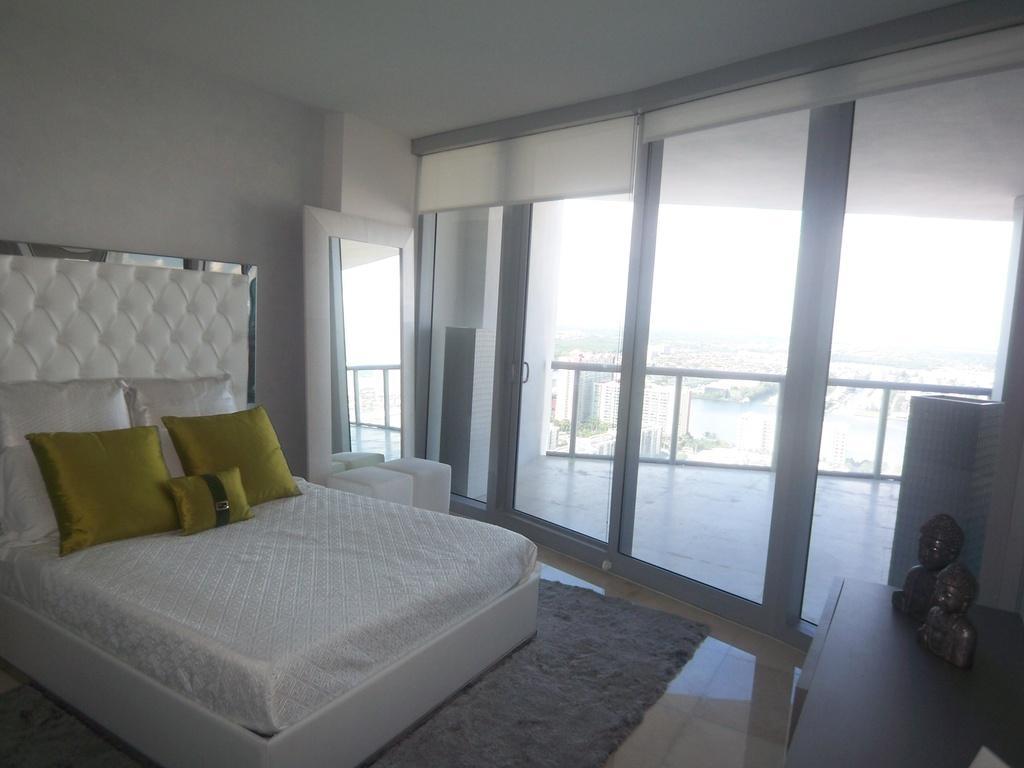Please provide a concise description of this image. In this image, we can see an inside view of a building. There is a bed in the bottom left of the image contains some pillows. There are sculptures on the table which is in the bottom right of the image. There is a door in the middle of the image. 